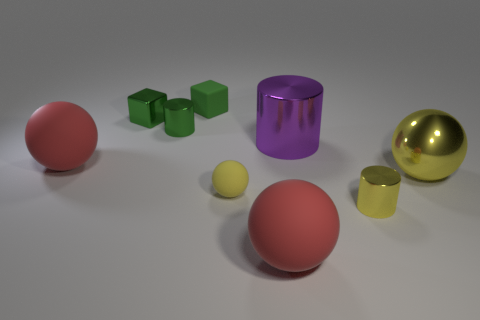How many cylinders are small yellow objects or rubber things?
Your answer should be very brief. 1. Are there any yellow shiny objects that have the same shape as the purple thing?
Your answer should be very brief. Yes. The yellow rubber object has what shape?
Your answer should be very brief. Sphere. How many things are big yellow metallic objects or small blocks?
Give a very brief answer. 3. Does the red matte sphere to the left of the small green matte block have the same size as the cylinder behind the big metal cylinder?
Your response must be concise. No. What number of other things are there of the same material as the large purple cylinder
Offer a very short reply. 4. Is the number of green cubes that are on the left side of the small rubber block greater than the number of green matte cubes that are in front of the big purple metal object?
Your answer should be compact. Yes. What material is the small ball that is to the left of the large purple cylinder?
Give a very brief answer. Rubber. Does the green rubber thing have the same shape as the big purple metallic object?
Make the answer very short. No. Are there any other things of the same color as the rubber cube?
Your answer should be very brief. Yes. 